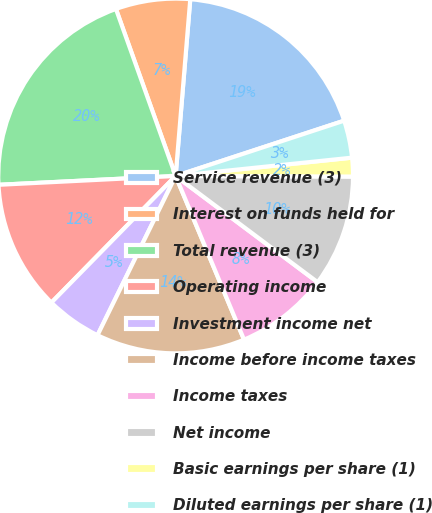<chart> <loc_0><loc_0><loc_500><loc_500><pie_chart><fcel>Service revenue (3)<fcel>Interest on funds held for<fcel>Total revenue (3)<fcel>Operating income<fcel>Investment income net<fcel>Income before income taxes<fcel>Income taxes<fcel>Net income<fcel>Basic earnings per share (1)<fcel>Diluted earnings per share (1)<nl><fcel>18.64%<fcel>6.78%<fcel>20.33%<fcel>11.86%<fcel>5.09%<fcel>13.56%<fcel>8.48%<fcel>10.17%<fcel>1.7%<fcel>3.4%<nl></chart> 